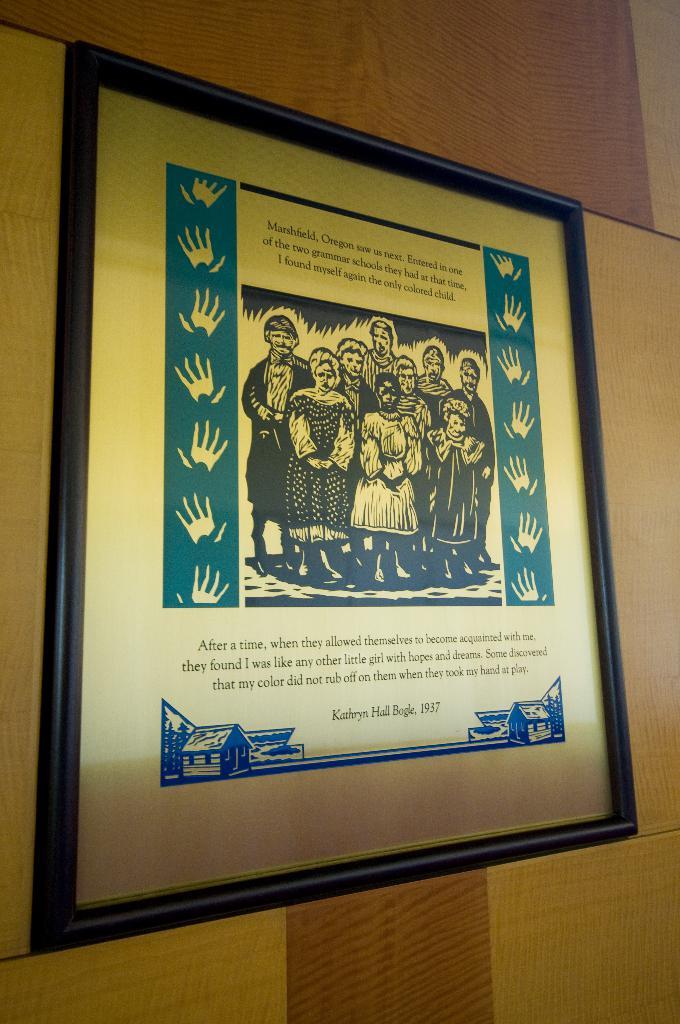What year was this written?
Keep it short and to the point. 1937. Who is the author of this?
Give a very brief answer. Unanswerable. 